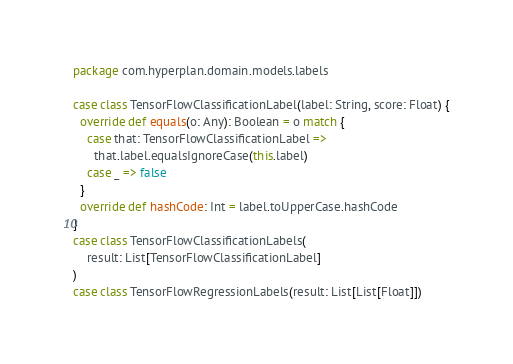Convert code to text. <code><loc_0><loc_0><loc_500><loc_500><_Scala_>package com.hyperplan.domain.models.labels

case class TensorFlowClassificationLabel(label: String, score: Float) {
  override def equals(o: Any): Boolean = o match {
    case that: TensorFlowClassificationLabel =>
      that.label.equalsIgnoreCase(this.label)
    case _ => false
  }
  override def hashCode: Int = label.toUpperCase.hashCode
}
case class TensorFlowClassificationLabels(
    result: List[TensorFlowClassificationLabel]
)
case class TensorFlowRegressionLabels(result: List[List[Float]])
</code> 